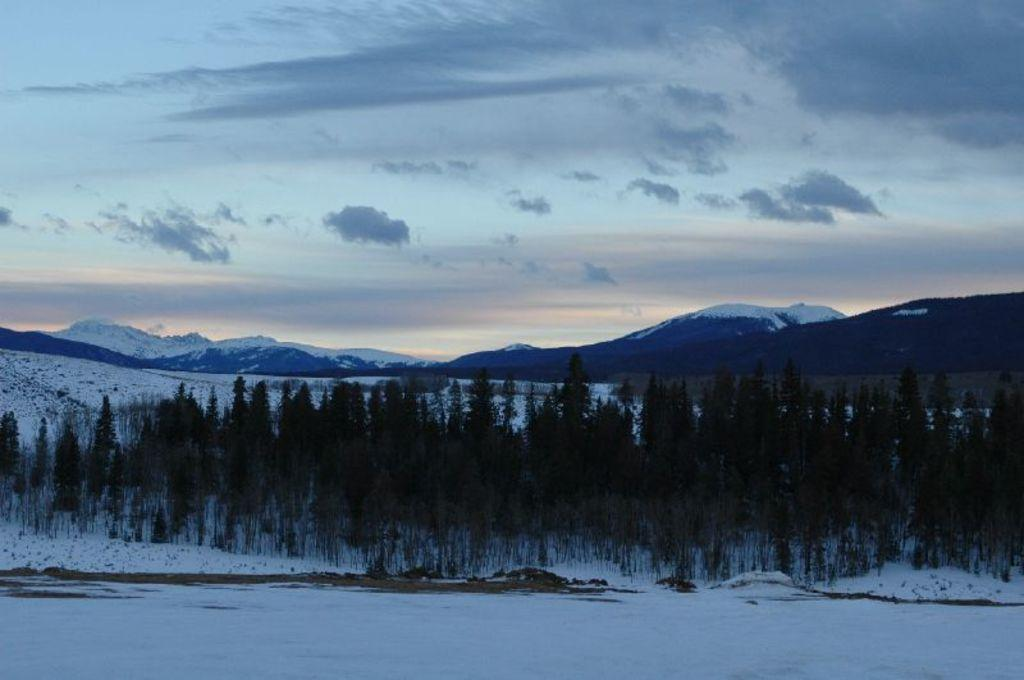What is the primary feature of the landscape in the image? There is snow in the image. What can be seen in the center of the image? There are trees in the center of the image. What type of cracker is being used to clean up the aftermath of the snow in the image? There is no cracker or any indication of an aftermath in the image; it simply shows snow and trees. 